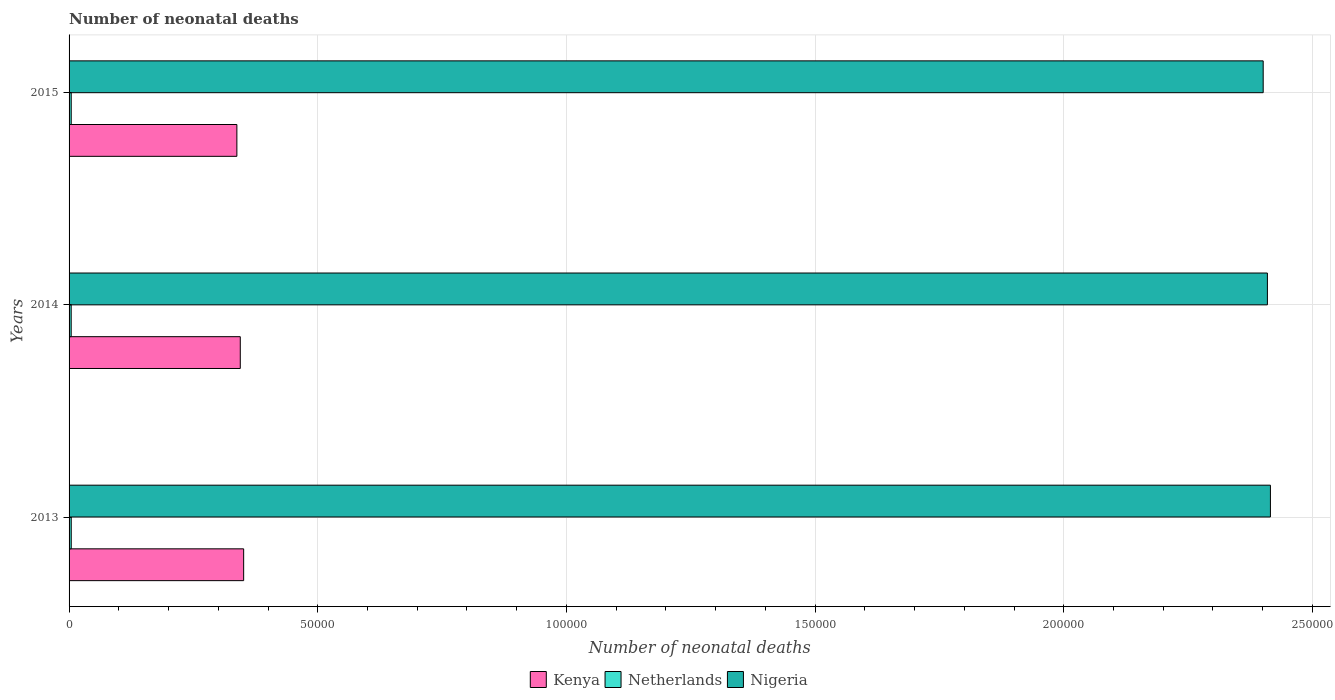Are the number of bars per tick equal to the number of legend labels?
Give a very brief answer. Yes. Are the number of bars on each tick of the Y-axis equal?
Offer a terse response. Yes. How many bars are there on the 1st tick from the bottom?
Provide a short and direct response. 3. What is the label of the 2nd group of bars from the top?
Provide a succinct answer. 2014. What is the number of neonatal deaths in in Netherlands in 2015?
Give a very brief answer. 432. Across all years, what is the maximum number of neonatal deaths in in Kenya?
Make the answer very short. 3.51e+04. Across all years, what is the minimum number of neonatal deaths in in Netherlands?
Your response must be concise. 426. In which year was the number of neonatal deaths in in Nigeria maximum?
Offer a terse response. 2013. In which year was the number of neonatal deaths in in Nigeria minimum?
Give a very brief answer. 2015. What is the total number of neonatal deaths in in Kenya in the graph?
Offer a terse response. 1.03e+05. What is the difference between the number of neonatal deaths in in Kenya in 2013 and that in 2014?
Offer a very short reply. 676. What is the difference between the number of neonatal deaths in in Nigeria in 2014 and the number of neonatal deaths in in Netherlands in 2013?
Provide a succinct answer. 2.41e+05. What is the average number of neonatal deaths in in Netherlands per year?
Your response must be concise. 431. In the year 2015, what is the difference between the number of neonatal deaths in in Kenya and number of neonatal deaths in in Nigeria?
Your response must be concise. -2.06e+05. In how many years, is the number of neonatal deaths in in Nigeria greater than 180000 ?
Provide a short and direct response. 3. What is the ratio of the number of neonatal deaths in in Kenya in 2014 to that in 2015?
Offer a terse response. 1.02. Is the difference between the number of neonatal deaths in in Kenya in 2013 and 2014 greater than the difference between the number of neonatal deaths in in Nigeria in 2013 and 2014?
Provide a succinct answer. Yes. What is the difference between the highest and the second highest number of neonatal deaths in in Kenya?
Offer a very short reply. 676. What is the difference between the highest and the lowest number of neonatal deaths in in Kenya?
Your response must be concise. 1362. Is the sum of the number of neonatal deaths in in Nigeria in 2013 and 2015 greater than the maximum number of neonatal deaths in in Kenya across all years?
Offer a very short reply. Yes. What does the 2nd bar from the top in 2014 represents?
Keep it short and to the point. Netherlands. What does the 2nd bar from the bottom in 2013 represents?
Keep it short and to the point. Netherlands. Is it the case that in every year, the sum of the number of neonatal deaths in in Netherlands and number of neonatal deaths in in Nigeria is greater than the number of neonatal deaths in in Kenya?
Provide a short and direct response. Yes. Are all the bars in the graph horizontal?
Give a very brief answer. Yes. How many years are there in the graph?
Your answer should be very brief. 3. What is the difference between two consecutive major ticks on the X-axis?
Make the answer very short. 5.00e+04. Does the graph contain grids?
Your answer should be very brief. Yes. How many legend labels are there?
Provide a short and direct response. 3. What is the title of the graph?
Provide a short and direct response. Number of neonatal deaths. What is the label or title of the X-axis?
Provide a succinct answer. Number of neonatal deaths. What is the Number of neonatal deaths of Kenya in 2013?
Offer a very short reply. 3.51e+04. What is the Number of neonatal deaths in Netherlands in 2013?
Your answer should be compact. 435. What is the Number of neonatal deaths of Nigeria in 2013?
Offer a terse response. 2.42e+05. What is the Number of neonatal deaths of Kenya in 2014?
Provide a succinct answer. 3.44e+04. What is the Number of neonatal deaths in Netherlands in 2014?
Offer a terse response. 426. What is the Number of neonatal deaths of Nigeria in 2014?
Your response must be concise. 2.41e+05. What is the Number of neonatal deaths of Kenya in 2015?
Provide a short and direct response. 3.37e+04. What is the Number of neonatal deaths of Netherlands in 2015?
Provide a succinct answer. 432. What is the Number of neonatal deaths in Nigeria in 2015?
Ensure brevity in your answer.  2.40e+05. Across all years, what is the maximum Number of neonatal deaths of Kenya?
Keep it short and to the point. 3.51e+04. Across all years, what is the maximum Number of neonatal deaths of Netherlands?
Make the answer very short. 435. Across all years, what is the maximum Number of neonatal deaths of Nigeria?
Your answer should be very brief. 2.42e+05. Across all years, what is the minimum Number of neonatal deaths of Kenya?
Your response must be concise. 3.37e+04. Across all years, what is the minimum Number of neonatal deaths of Netherlands?
Offer a very short reply. 426. Across all years, what is the minimum Number of neonatal deaths in Nigeria?
Provide a succinct answer. 2.40e+05. What is the total Number of neonatal deaths of Kenya in the graph?
Ensure brevity in your answer.  1.03e+05. What is the total Number of neonatal deaths of Netherlands in the graph?
Give a very brief answer. 1293. What is the total Number of neonatal deaths in Nigeria in the graph?
Give a very brief answer. 7.23e+05. What is the difference between the Number of neonatal deaths in Kenya in 2013 and that in 2014?
Provide a short and direct response. 676. What is the difference between the Number of neonatal deaths in Netherlands in 2013 and that in 2014?
Ensure brevity in your answer.  9. What is the difference between the Number of neonatal deaths in Nigeria in 2013 and that in 2014?
Give a very brief answer. 606. What is the difference between the Number of neonatal deaths of Kenya in 2013 and that in 2015?
Give a very brief answer. 1362. What is the difference between the Number of neonatal deaths of Nigeria in 2013 and that in 2015?
Provide a short and direct response. 1455. What is the difference between the Number of neonatal deaths in Kenya in 2014 and that in 2015?
Offer a very short reply. 686. What is the difference between the Number of neonatal deaths of Nigeria in 2014 and that in 2015?
Ensure brevity in your answer.  849. What is the difference between the Number of neonatal deaths of Kenya in 2013 and the Number of neonatal deaths of Netherlands in 2014?
Provide a short and direct response. 3.47e+04. What is the difference between the Number of neonatal deaths in Kenya in 2013 and the Number of neonatal deaths in Nigeria in 2014?
Make the answer very short. -2.06e+05. What is the difference between the Number of neonatal deaths of Netherlands in 2013 and the Number of neonatal deaths of Nigeria in 2014?
Ensure brevity in your answer.  -2.41e+05. What is the difference between the Number of neonatal deaths of Kenya in 2013 and the Number of neonatal deaths of Netherlands in 2015?
Ensure brevity in your answer.  3.47e+04. What is the difference between the Number of neonatal deaths of Kenya in 2013 and the Number of neonatal deaths of Nigeria in 2015?
Your response must be concise. -2.05e+05. What is the difference between the Number of neonatal deaths in Netherlands in 2013 and the Number of neonatal deaths in Nigeria in 2015?
Provide a succinct answer. -2.40e+05. What is the difference between the Number of neonatal deaths in Kenya in 2014 and the Number of neonatal deaths in Netherlands in 2015?
Ensure brevity in your answer.  3.40e+04. What is the difference between the Number of neonatal deaths in Kenya in 2014 and the Number of neonatal deaths in Nigeria in 2015?
Your response must be concise. -2.06e+05. What is the difference between the Number of neonatal deaths in Netherlands in 2014 and the Number of neonatal deaths in Nigeria in 2015?
Your answer should be very brief. -2.40e+05. What is the average Number of neonatal deaths in Kenya per year?
Give a very brief answer. 3.44e+04. What is the average Number of neonatal deaths in Netherlands per year?
Offer a very short reply. 431. What is the average Number of neonatal deaths of Nigeria per year?
Make the answer very short. 2.41e+05. In the year 2013, what is the difference between the Number of neonatal deaths in Kenya and Number of neonatal deaths in Netherlands?
Provide a short and direct response. 3.47e+04. In the year 2013, what is the difference between the Number of neonatal deaths of Kenya and Number of neonatal deaths of Nigeria?
Your response must be concise. -2.06e+05. In the year 2013, what is the difference between the Number of neonatal deaths of Netherlands and Number of neonatal deaths of Nigeria?
Provide a succinct answer. -2.41e+05. In the year 2014, what is the difference between the Number of neonatal deaths in Kenya and Number of neonatal deaths in Netherlands?
Keep it short and to the point. 3.40e+04. In the year 2014, what is the difference between the Number of neonatal deaths of Kenya and Number of neonatal deaths of Nigeria?
Make the answer very short. -2.07e+05. In the year 2014, what is the difference between the Number of neonatal deaths of Netherlands and Number of neonatal deaths of Nigeria?
Ensure brevity in your answer.  -2.41e+05. In the year 2015, what is the difference between the Number of neonatal deaths in Kenya and Number of neonatal deaths in Netherlands?
Give a very brief answer. 3.33e+04. In the year 2015, what is the difference between the Number of neonatal deaths in Kenya and Number of neonatal deaths in Nigeria?
Provide a succinct answer. -2.06e+05. In the year 2015, what is the difference between the Number of neonatal deaths in Netherlands and Number of neonatal deaths in Nigeria?
Keep it short and to the point. -2.40e+05. What is the ratio of the Number of neonatal deaths in Kenya in 2013 to that in 2014?
Give a very brief answer. 1.02. What is the ratio of the Number of neonatal deaths in Netherlands in 2013 to that in 2014?
Offer a very short reply. 1.02. What is the ratio of the Number of neonatal deaths of Kenya in 2013 to that in 2015?
Your answer should be compact. 1.04. What is the ratio of the Number of neonatal deaths of Kenya in 2014 to that in 2015?
Give a very brief answer. 1.02. What is the ratio of the Number of neonatal deaths of Netherlands in 2014 to that in 2015?
Make the answer very short. 0.99. What is the difference between the highest and the second highest Number of neonatal deaths in Kenya?
Your answer should be very brief. 676. What is the difference between the highest and the second highest Number of neonatal deaths in Nigeria?
Provide a succinct answer. 606. What is the difference between the highest and the lowest Number of neonatal deaths of Kenya?
Your answer should be compact. 1362. What is the difference between the highest and the lowest Number of neonatal deaths of Netherlands?
Offer a very short reply. 9. What is the difference between the highest and the lowest Number of neonatal deaths in Nigeria?
Make the answer very short. 1455. 